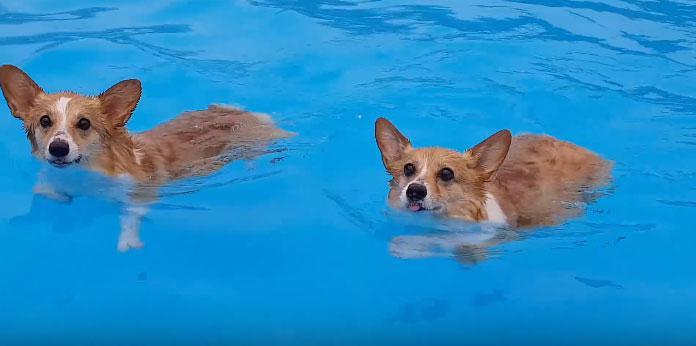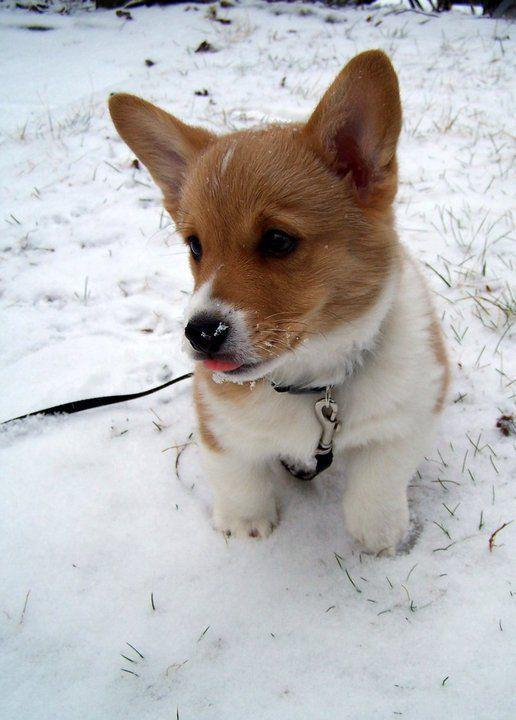The first image is the image on the left, the second image is the image on the right. Examine the images to the left and right. Is the description "One of the dogs has a stick in its mouth." accurate? Answer yes or no. No. The first image is the image on the left, the second image is the image on the right. Considering the images on both sides, is "One image shows at least one dog swimming forward with nothing carried in its mouth, and the other image contains one sitting dog wearing a leash." valid? Answer yes or no. Yes. 